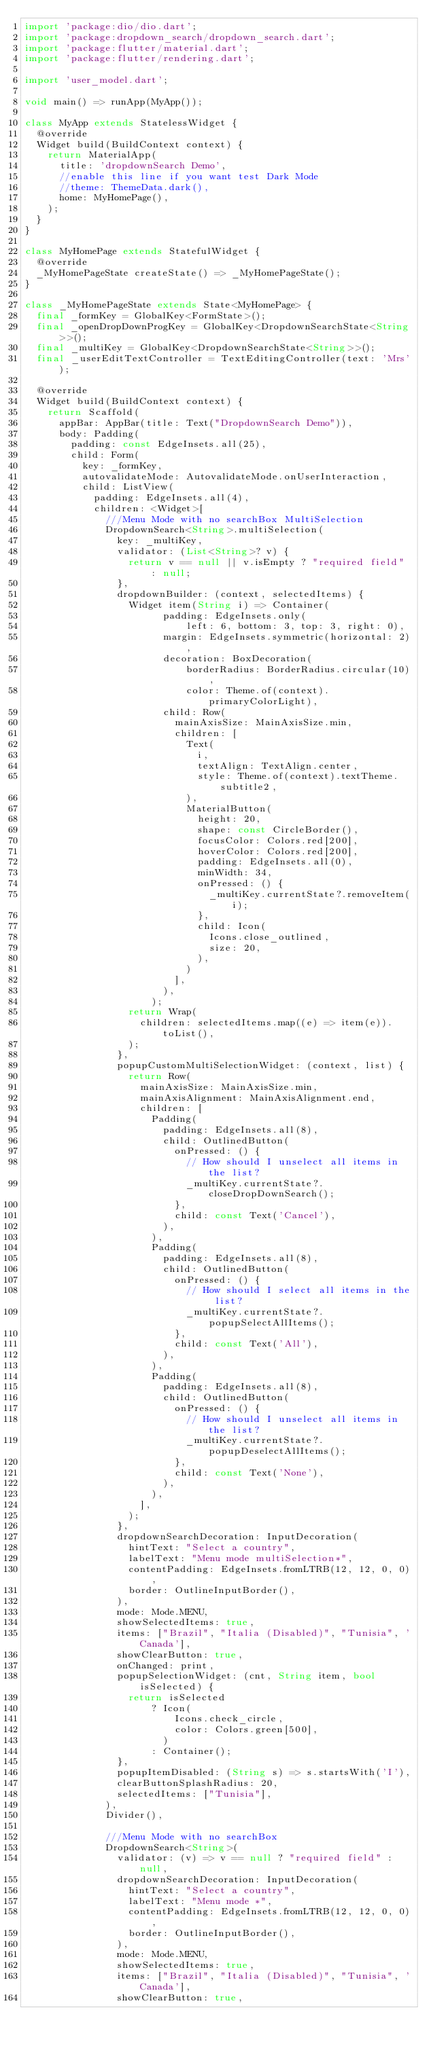Convert code to text. <code><loc_0><loc_0><loc_500><loc_500><_Dart_>import 'package:dio/dio.dart';
import 'package:dropdown_search/dropdown_search.dart';
import 'package:flutter/material.dart';
import 'package:flutter/rendering.dart';

import 'user_model.dart';

void main() => runApp(MyApp());

class MyApp extends StatelessWidget {
  @override
  Widget build(BuildContext context) {
    return MaterialApp(
      title: 'dropdownSearch Demo',
      //enable this line if you want test Dark Mode
      //theme: ThemeData.dark(),
      home: MyHomePage(),
    );
  }
}

class MyHomePage extends StatefulWidget {
  @override
  _MyHomePageState createState() => _MyHomePageState();
}

class _MyHomePageState extends State<MyHomePage> {
  final _formKey = GlobalKey<FormState>();
  final _openDropDownProgKey = GlobalKey<DropdownSearchState<String>>();
  final _multiKey = GlobalKey<DropdownSearchState<String>>();
  final _userEditTextController = TextEditingController(text: 'Mrs');

  @override
  Widget build(BuildContext context) {
    return Scaffold(
      appBar: AppBar(title: Text("DropdownSearch Demo")),
      body: Padding(
        padding: const EdgeInsets.all(25),
        child: Form(
          key: _formKey,
          autovalidateMode: AutovalidateMode.onUserInteraction,
          child: ListView(
            padding: EdgeInsets.all(4),
            children: <Widget>[
              ///Menu Mode with no searchBox MultiSelection
              DropdownSearch<String>.multiSelection(
                key: _multiKey,
                validator: (List<String>? v) {
                  return v == null || v.isEmpty ? "required field" : null;
                },
                dropdownBuilder: (context, selectedItems) {
                  Widget item(String i) => Container(
                        padding: EdgeInsets.only(
                            left: 6, bottom: 3, top: 3, right: 0),
                        margin: EdgeInsets.symmetric(horizontal: 2),
                        decoration: BoxDecoration(
                            borderRadius: BorderRadius.circular(10),
                            color: Theme.of(context).primaryColorLight),
                        child: Row(
                          mainAxisSize: MainAxisSize.min,
                          children: [
                            Text(
                              i,
                              textAlign: TextAlign.center,
                              style: Theme.of(context).textTheme.subtitle2,
                            ),
                            MaterialButton(
                              height: 20,
                              shape: const CircleBorder(),
                              focusColor: Colors.red[200],
                              hoverColor: Colors.red[200],
                              padding: EdgeInsets.all(0),
                              minWidth: 34,
                              onPressed: () {
                                _multiKey.currentState?.removeItem(i);
                              },
                              child: Icon(
                                Icons.close_outlined,
                                size: 20,
                              ),
                            )
                          ],
                        ),
                      );
                  return Wrap(
                    children: selectedItems.map((e) => item(e)).toList(),
                  );
                },
                popupCustomMultiSelectionWidget: (context, list) {
                  return Row(
                    mainAxisSize: MainAxisSize.min,
                    mainAxisAlignment: MainAxisAlignment.end,
                    children: [
                      Padding(
                        padding: EdgeInsets.all(8),
                        child: OutlinedButton(
                          onPressed: () {
                            // How should I unselect all items in the list?
                            _multiKey.currentState?.closeDropDownSearch();
                          },
                          child: const Text('Cancel'),
                        ),
                      ),
                      Padding(
                        padding: EdgeInsets.all(8),
                        child: OutlinedButton(
                          onPressed: () {
                            // How should I select all items in the list?
                            _multiKey.currentState?.popupSelectAllItems();
                          },
                          child: const Text('All'),
                        ),
                      ),
                      Padding(
                        padding: EdgeInsets.all(8),
                        child: OutlinedButton(
                          onPressed: () {
                            // How should I unselect all items in the list?
                            _multiKey.currentState?.popupDeselectAllItems();
                          },
                          child: const Text('None'),
                        ),
                      ),
                    ],
                  );
                },
                dropdownSearchDecoration: InputDecoration(
                  hintText: "Select a country",
                  labelText: "Menu mode multiSelection*",
                  contentPadding: EdgeInsets.fromLTRB(12, 12, 0, 0),
                  border: OutlineInputBorder(),
                ),
                mode: Mode.MENU,
                showSelectedItems: true,
                items: ["Brazil", "Italia (Disabled)", "Tunisia", 'Canada'],
                showClearButton: true,
                onChanged: print,
                popupSelectionWidget: (cnt, String item, bool isSelected) {
                  return isSelected
                      ? Icon(
                          Icons.check_circle,
                          color: Colors.green[500],
                        )
                      : Container();
                },
                popupItemDisabled: (String s) => s.startsWith('I'),
                clearButtonSplashRadius: 20,
                selectedItems: ["Tunisia"],
              ),
              Divider(),

              ///Menu Mode with no searchBox
              DropdownSearch<String>(
                validator: (v) => v == null ? "required field" : null,
                dropdownSearchDecoration: InputDecoration(
                  hintText: "Select a country",
                  labelText: "Menu mode *",
                  contentPadding: EdgeInsets.fromLTRB(12, 12, 0, 0),
                  border: OutlineInputBorder(),
                ),
                mode: Mode.MENU,
                showSelectedItems: true,
                items: ["Brazil", "Italia (Disabled)", "Tunisia", 'Canada'],
                showClearButton: true,</code> 